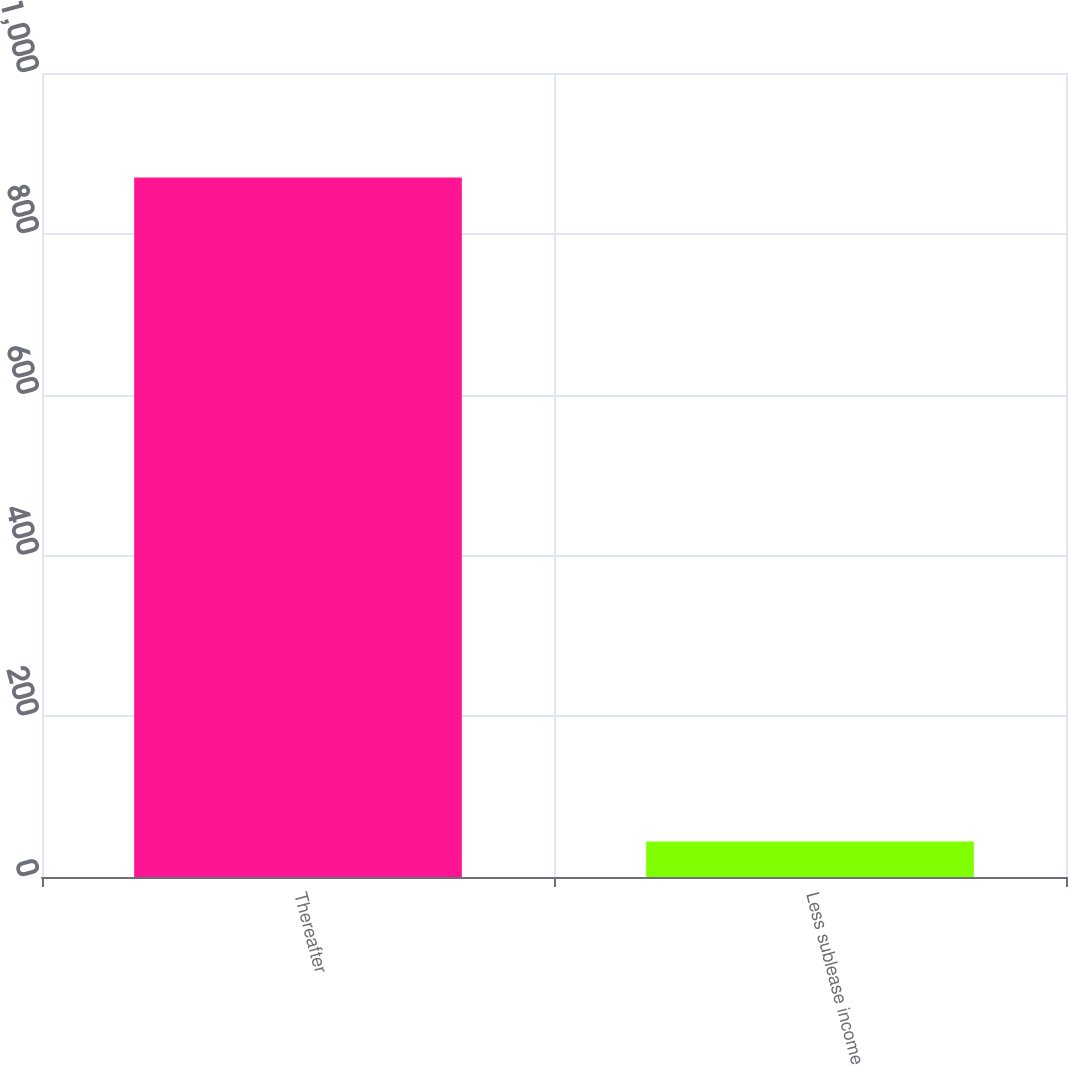Convert chart. <chart><loc_0><loc_0><loc_500><loc_500><bar_chart><fcel>Thereafter<fcel>Less sublease income<nl><fcel>870<fcel>44<nl></chart> 